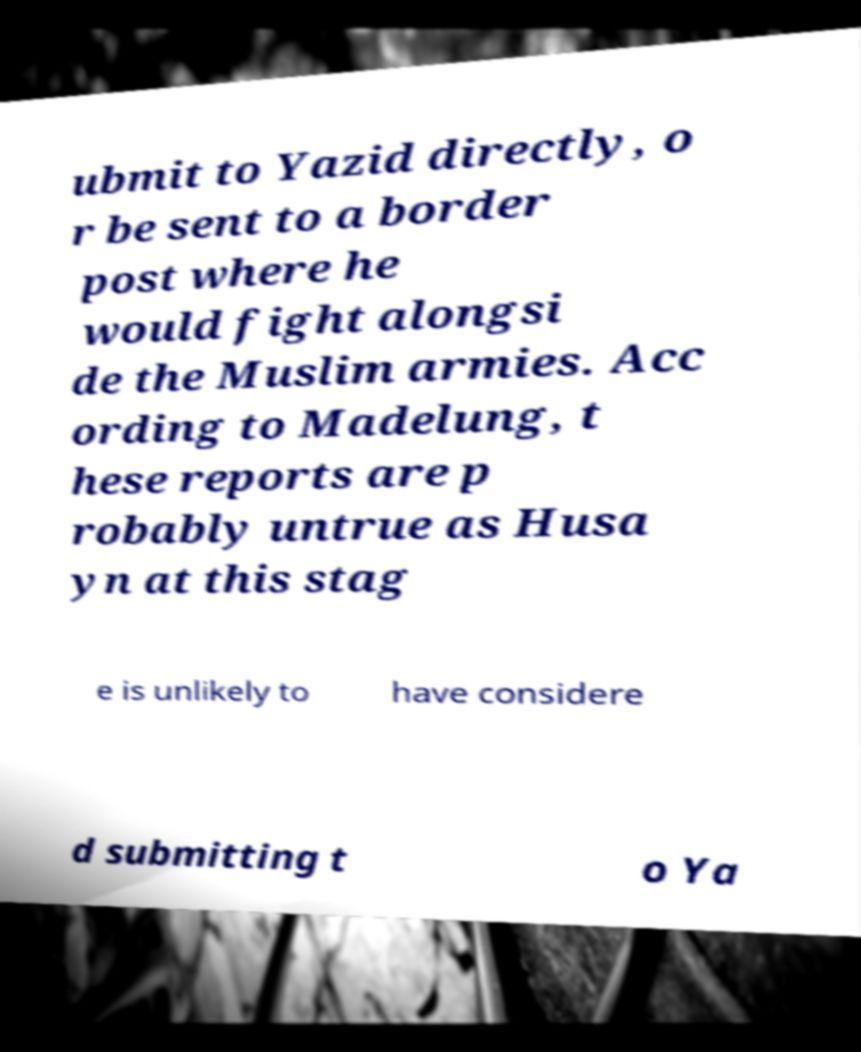I need the written content from this picture converted into text. Can you do that? ubmit to Yazid directly, o r be sent to a border post where he would fight alongsi de the Muslim armies. Acc ording to Madelung, t hese reports are p robably untrue as Husa yn at this stag e is unlikely to have considere d submitting t o Ya 